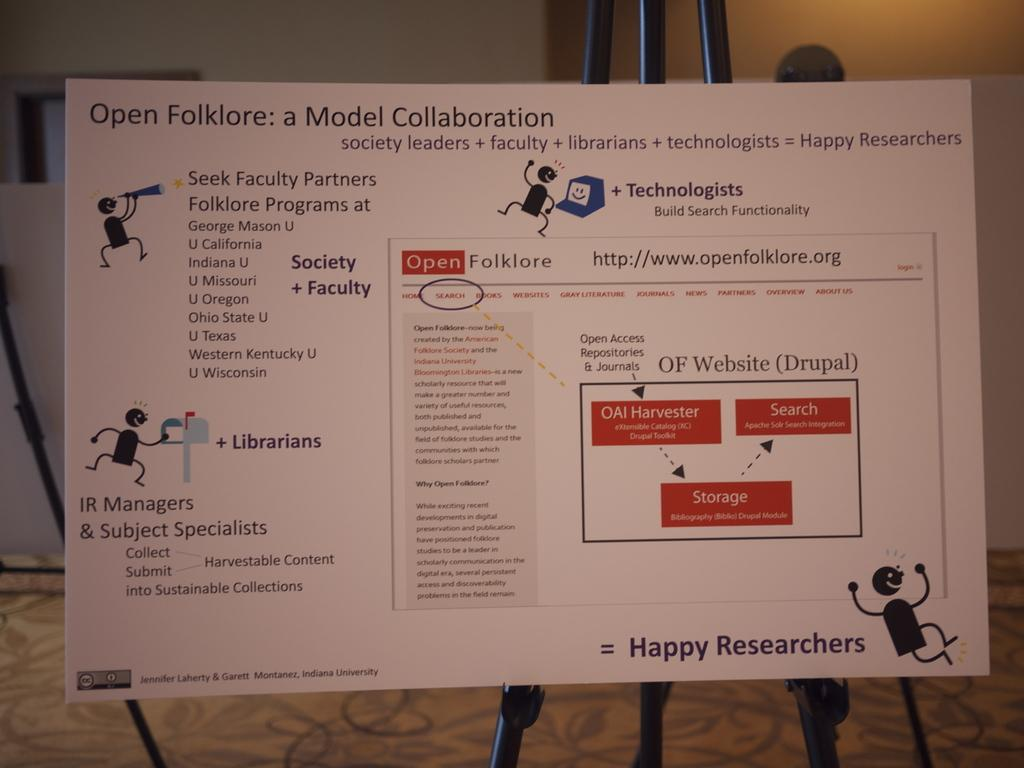<image>
Give a short and clear explanation of the subsequent image. A poster explains concepts and details behind the Open Folklore collaboration model. 